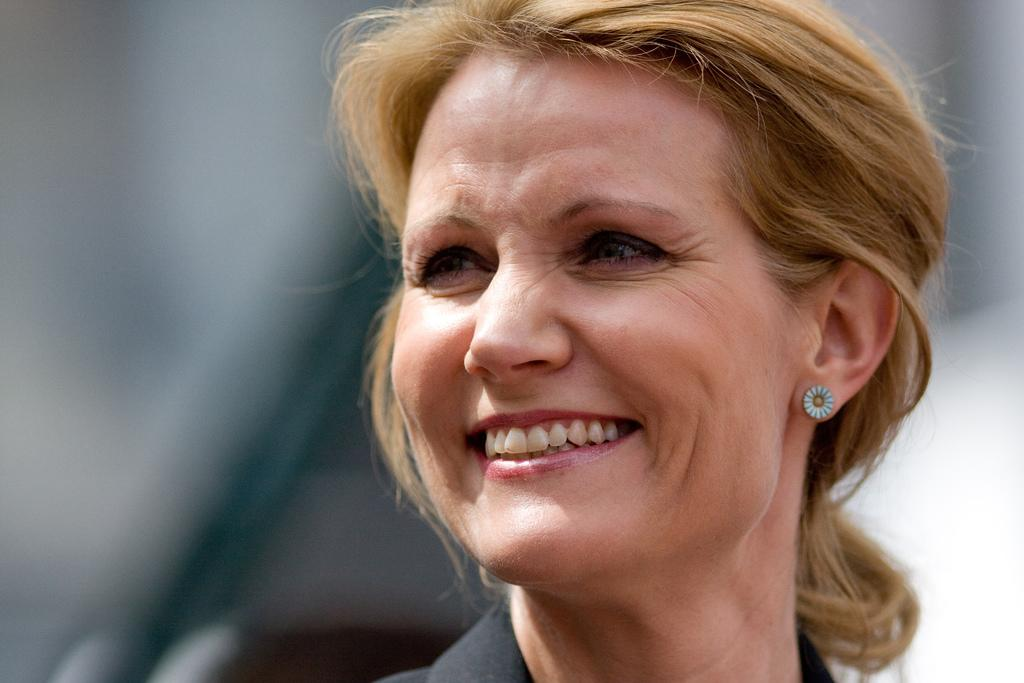What is the main subject of the image? There is a woman's face in the image. What expression does the woman have? The woman is smiling. Can you describe the background of the image? The background of the image is blurred. What type of pollution can be seen in the image? There is no pollution present in the image; it features a woman's face with a blurred background. Is there a tank visible in the image? There is no tank present in the image. 